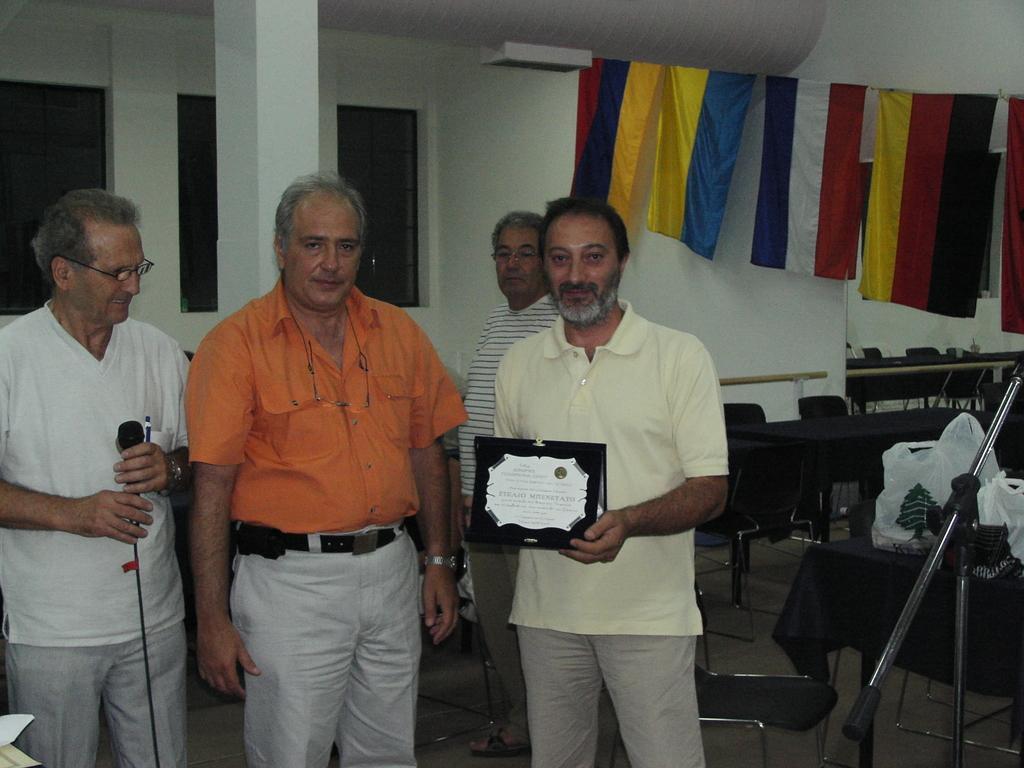Could you give a brief overview of what you see in this image? In this image, we can see people and some are wearing glasses and on the right, there is a person standing and holding an award and on the left, we can see a person holding a mic. In the background, there are windows and there is a wall and we can see some clothes hanging on the rope and there are chairs, tables, stands and some bags. At the bottom, there is a floor. 